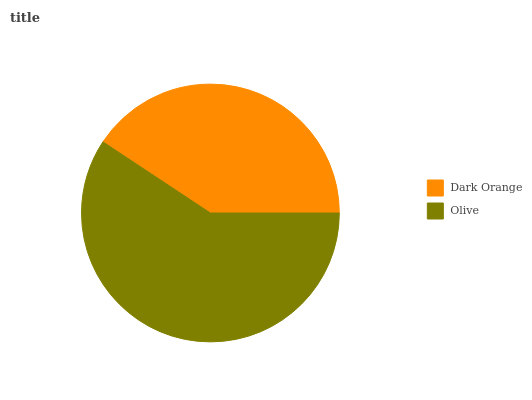Is Dark Orange the minimum?
Answer yes or no. Yes. Is Olive the maximum?
Answer yes or no. Yes. Is Olive the minimum?
Answer yes or no. No. Is Olive greater than Dark Orange?
Answer yes or no. Yes. Is Dark Orange less than Olive?
Answer yes or no. Yes. Is Dark Orange greater than Olive?
Answer yes or no. No. Is Olive less than Dark Orange?
Answer yes or no. No. Is Olive the high median?
Answer yes or no. Yes. Is Dark Orange the low median?
Answer yes or no. Yes. Is Dark Orange the high median?
Answer yes or no. No. Is Olive the low median?
Answer yes or no. No. 